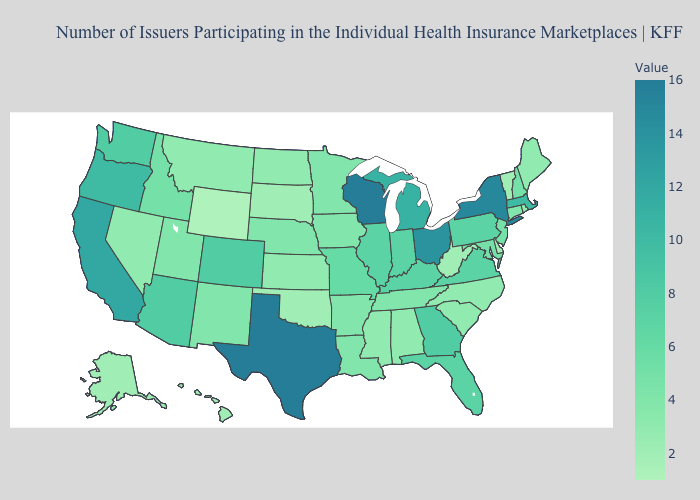Does Tennessee have the lowest value in the South?
Keep it brief. No. Does Wyoming have the lowest value in the West?
Concise answer only. Yes. Is the legend a continuous bar?
Short answer required. Yes. Is the legend a continuous bar?
Answer briefly. Yes. Which states have the lowest value in the USA?
Be succinct. Wyoming. 